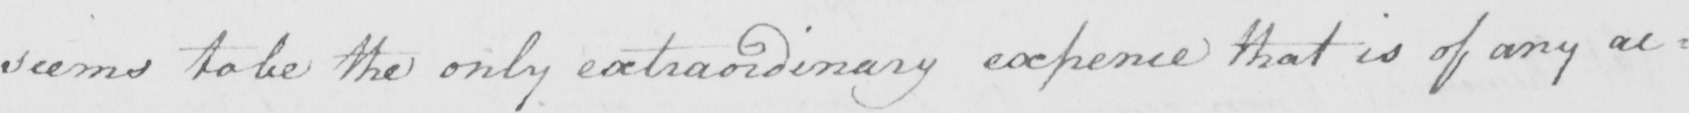Transcribe the text shown in this historical manuscript line. seems to be the only extraordinary expence that is of any ac= 